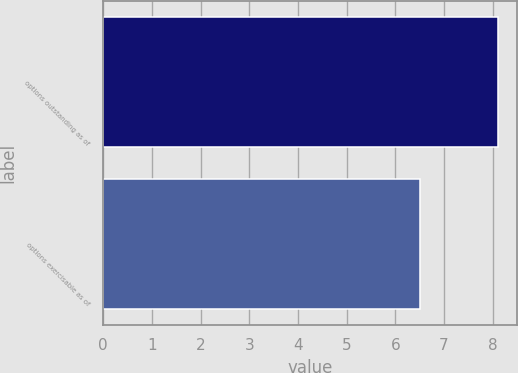Convert chart. <chart><loc_0><loc_0><loc_500><loc_500><bar_chart><fcel>options outstanding as of<fcel>options exercisable as of<nl><fcel>8.1<fcel>6.5<nl></chart> 